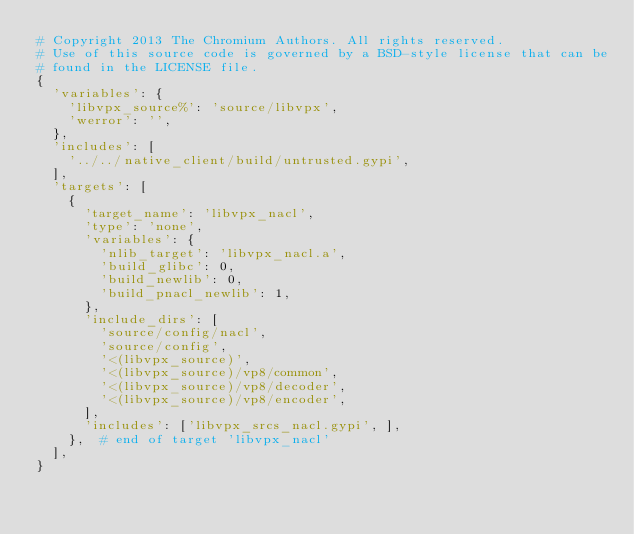Convert code to text. <code><loc_0><loc_0><loc_500><loc_500><_Python_># Copyright 2013 The Chromium Authors. All rights reserved.
# Use of this source code is governed by a BSD-style license that can be
# found in the LICENSE file.
{
  'variables': {
    'libvpx_source%': 'source/libvpx',
    'werror': '',
  },
  'includes': [
    '../../native_client/build/untrusted.gypi',
  ],
  'targets': [
    {
      'target_name': 'libvpx_nacl',
      'type': 'none',
      'variables': {
        'nlib_target': 'libvpx_nacl.a',
        'build_glibc': 0,
        'build_newlib': 0,
        'build_pnacl_newlib': 1,
      },
      'include_dirs': [
        'source/config/nacl',
        'source/config',
        '<(libvpx_source)',
        '<(libvpx_source)/vp8/common',
        '<(libvpx_source)/vp8/decoder',
        '<(libvpx_source)/vp8/encoder',
      ],
      'includes': ['libvpx_srcs_nacl.gypi', ],
    },  # end of target 'libvpx_nacl'
  ],
}
</code> 